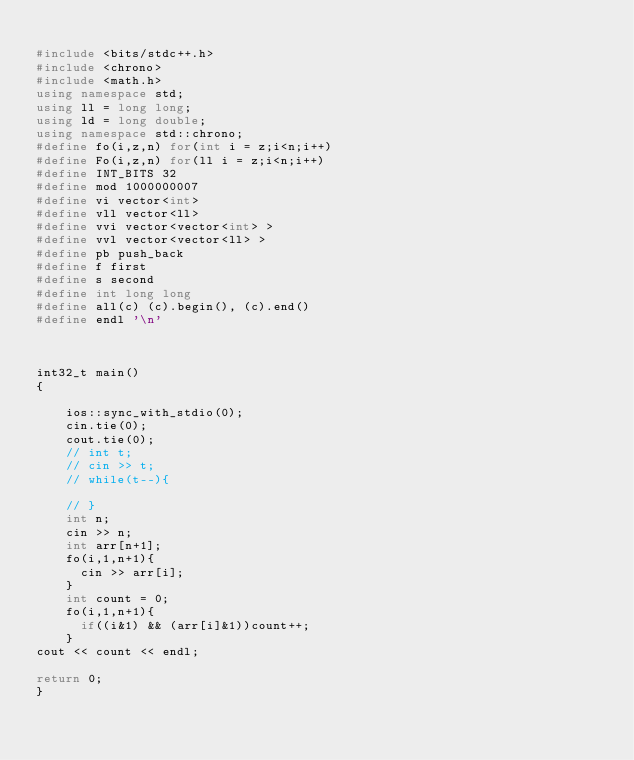Convert code to text. <code><loc_0><loc_0><loc_500><loc_500><_C++_>
#include <bits/stdc++.h>
#include <chrono>
#include <math.h>
using namespace std;
using ll = long long;
using ld = long double;
using namespace std::chrono; 
#define fo(i,z,n) for(int i = z;i<n;i++)
#define Fo(i,z,n) for(ll i = z;i<n;i++)
#define INT_BITS 32
#define mod 1000000007
#define vi vector<int>
#define vll vector<ll>
#define vvi vector<vector<int> >
#define vvl vector<vector<ll> >
#define pb push_back
#define f first
#define s second 
#define int long long
#define all(c) (c).begin(), (c).end()
#define endl '\n'



int32_t main()
{
 
    ios::sync_with_stdio(0);
    cin.tie(0);
    cout.tie(0);
    // int t;
    // cin >> t;
    // while(t--){

    // }
    int n;
    cin >> n;
    int arr[n+1];
    fo(i,1,n+1){
    	cin >> arr[i];
    }
    int count = 0;
    fo(i,1,n+1){
    	if((i&1) && (arr[i]&1))count++;
    }
cout << count << endl;

return 0;
}

 </code> 